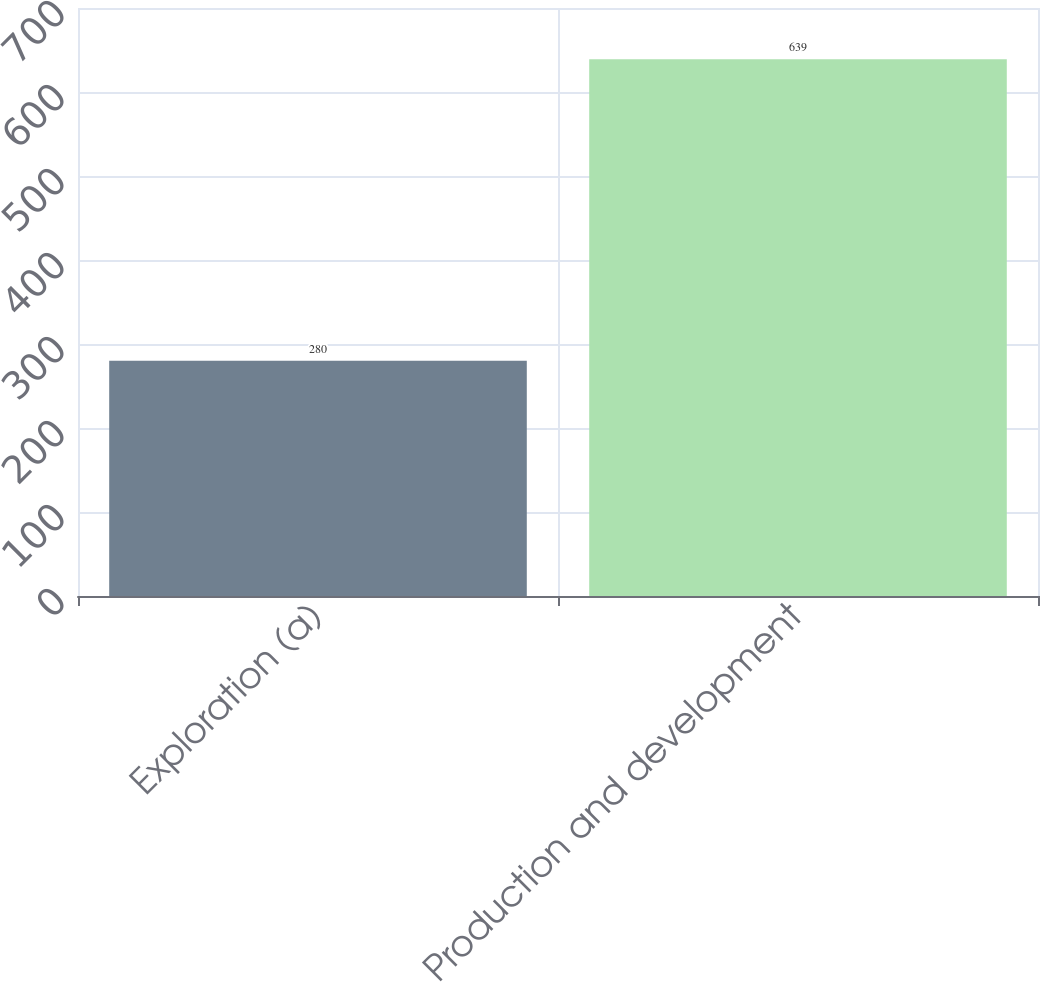Convert chart to OTSL. <chart><loc_0><loc_0><loc_500><loc_500><bar_chart><fcel>Exploration (a)<fcel>Production and development<nl><fcel>280<fcel>639<nl></chart> 